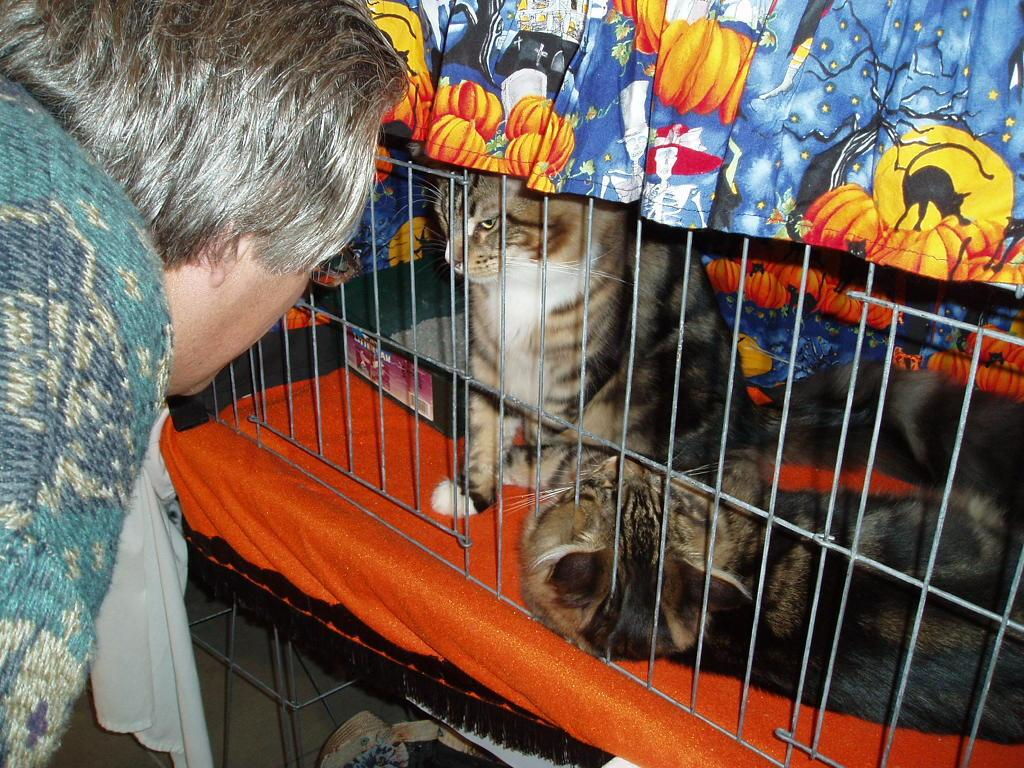What is inside the cage in the image? There are animals in a cage in the image. Who is present in the image besides the animals? There is a person staring at the animals in the image. What can be seen in the background of the image? There is a colorful cloth in the image. What is located under the cage in the image? There are objects under the cage in the image. Can you see any grapes or bananas in the image? There are no grapes or bananas present in the image. 